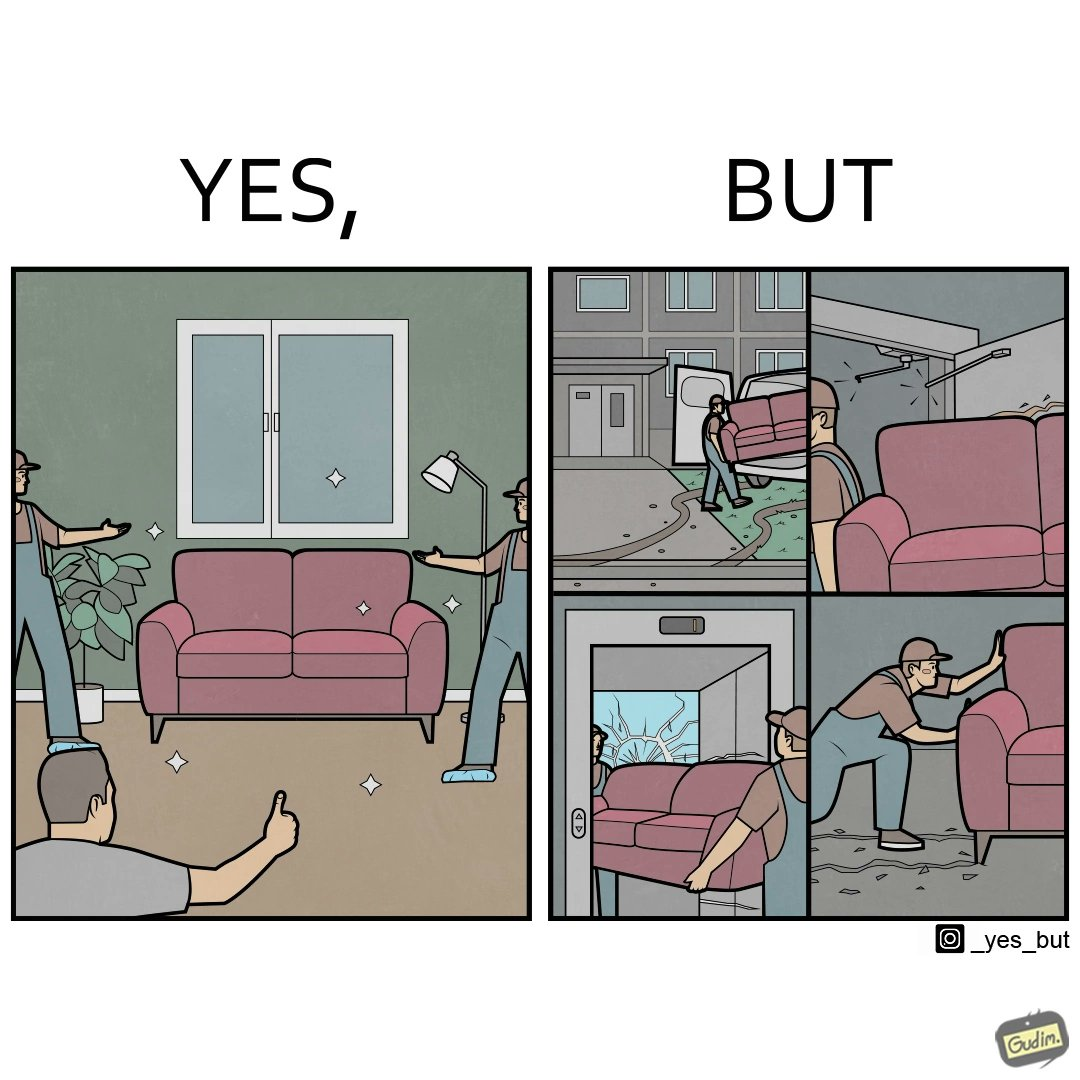Compare the left and right sides of this image. In the left part of the image: A man happy with movers who have helped move in a sofa In the right part of the image: Images show how movers have damaged a house while moving in furniture 